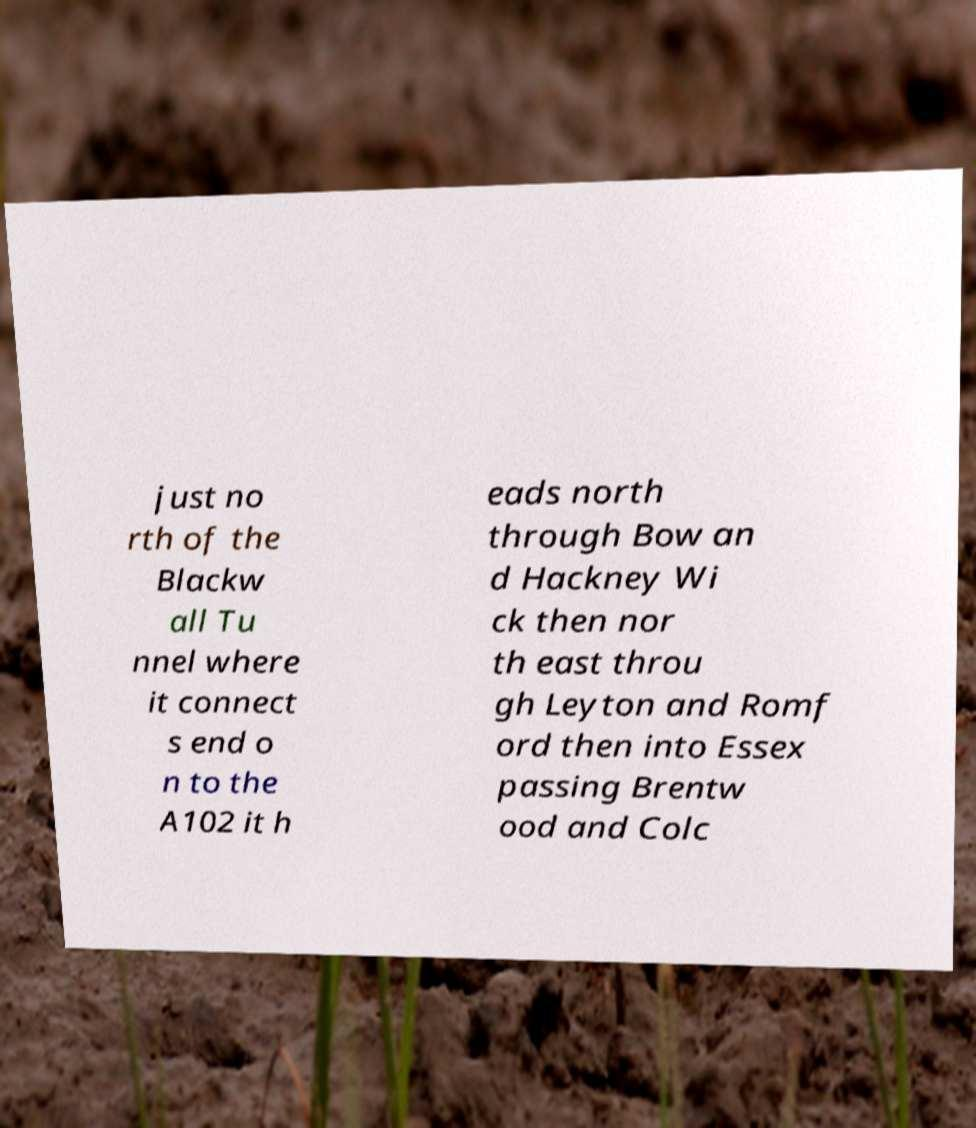Could you assist in decoding the text presented in this image and type it out clearly? just no rth of the Blackw all Tu nnel where it connect s end o n to the A102 it h eads north through Bow an d Hackney Wi ck then nor th east throu gh Leyton and Romf ord then into Essex passing Brentw ood and Colc 